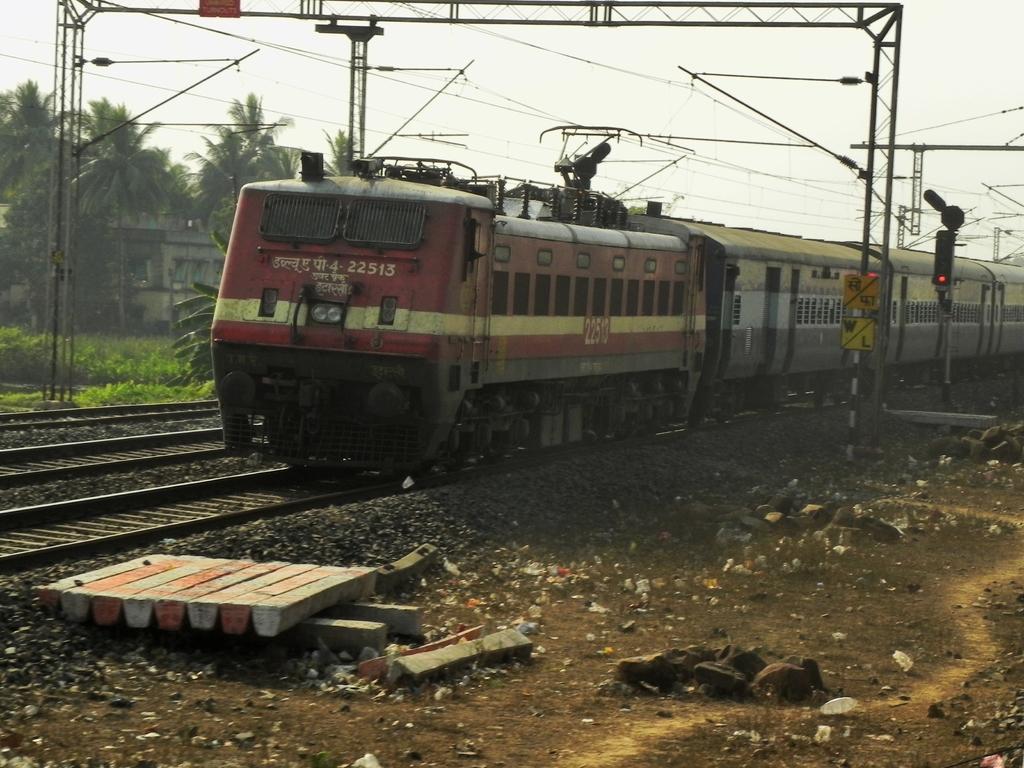Can you describe this image briefly? In this image I can see a train which is red, yellow and black in color on the railway track and to the left side of the image I can see few other railway tracks. I can see the ground, few stones, few metal rods, few wires, a traffic signal, few trees, a building and the sky in the background. 